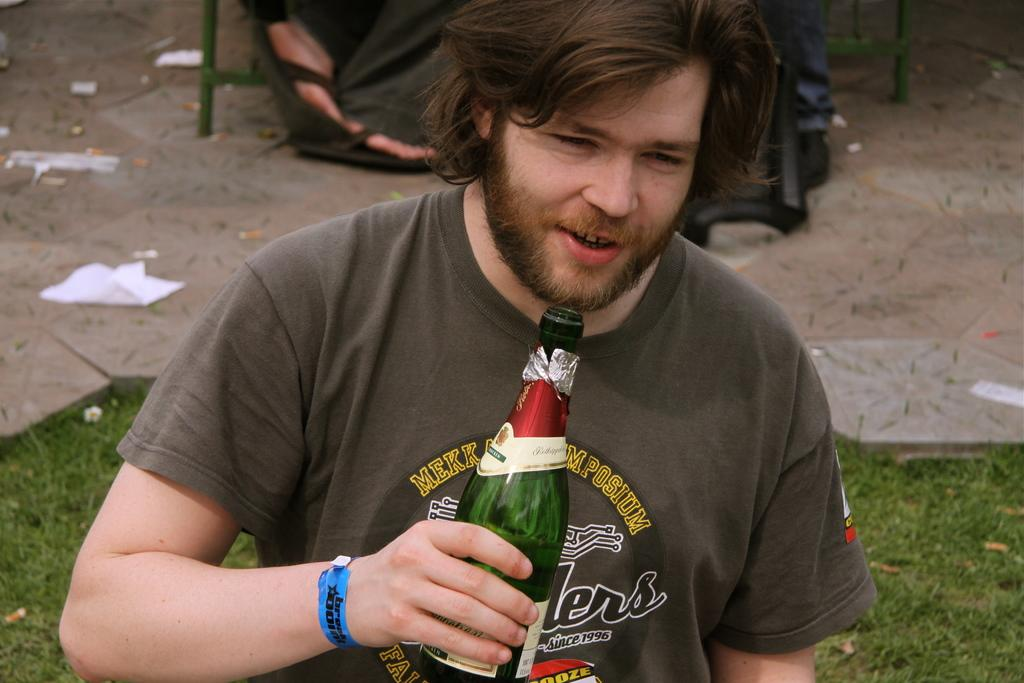What is the person in the image doing? The person is holding a bottle and has their mouth open. What might the person be doing with the bottle? The person might be drinking from the bottle or about to drink from it. Can you describe the legs of the other person in the image? The legs of the other person are visible in the image, but no other details are provided. What type of surface is the person standing on? The person is standing on grass, which is on the floor. How does the person compare to the maid in the image? There is no mention of a maid in the image, so it is not possible to make a comparison. 